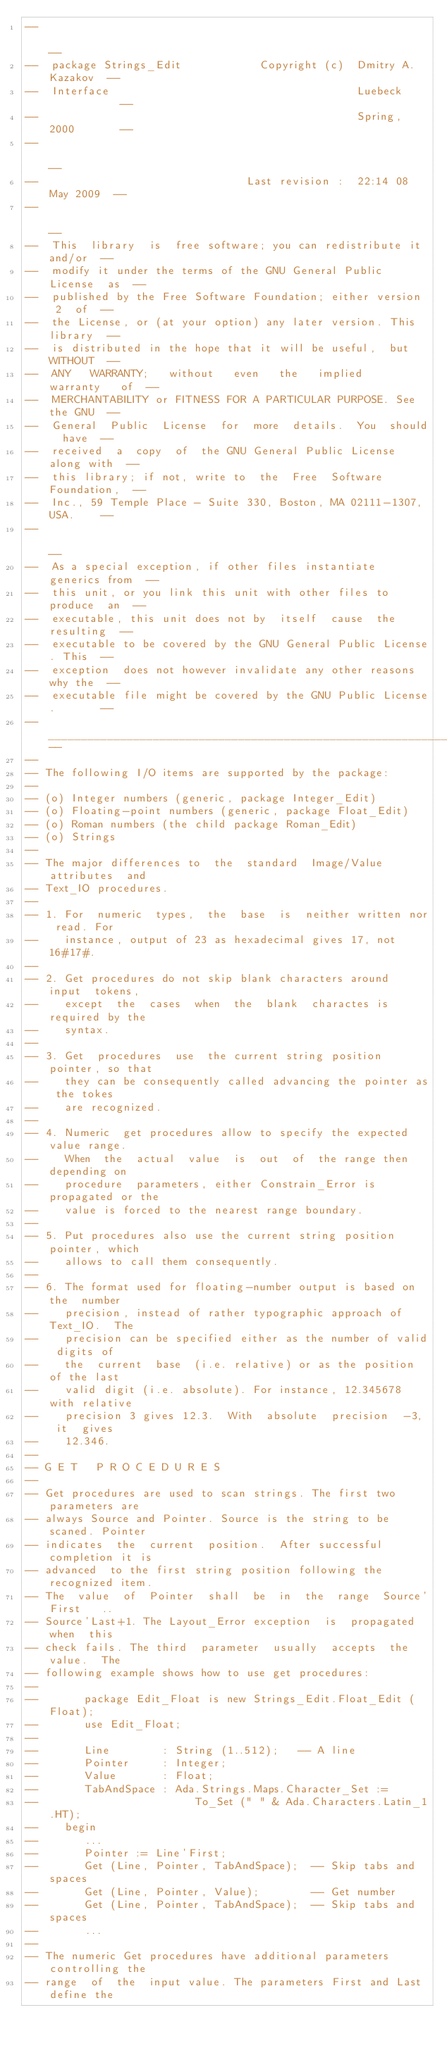Convert code to text. <code><loc_0><loc_0><loc_500><loc_500><_Ada_>--                                                                    --
--  package Strings_Edit            Copyright (c)  Dmitry A. Kazakov  --
--  Interface                                      Luebeck            --
--                                                 Spring, 2000       --
--                                                                    --
--                                Last revision :  22:14 08 May 2009  --
--                                                                    --
--  This  library  is  free software; you can redistribute it and/or  --
--  modify it under the terms of the GNU General Public  License  as  --
--  published by the Free Software Foundation; either version  2  of  --
--  the License, or (at your option) any later version. This library  --
--  is distributed in the hope that it will be useful,  but  WITHOUT  --
--  ANY   WARRANTY;   without   even   the   implied   warranty   of  --
--  MERCHANTABILITY or FITNESS FOR A PARTICULAR PURPOSE. See the GNU  --
--  General  Public  License  for  more  details.  You  should  have  --
--  received  a  copy  of  the GNU General Public License along with  --
--  this library; if not, write to  the  Free  Software  Foundation,  --
--  Inc., 59 Temple Place - Suite 330, Boston, MA 02111-1307, USA.    --
--                                                                    --
--  As a special exception, if other files instantiate generics from  --
--  this unit, or you link this unit with other files to produce  an  --
--  executable, this unit does not by  itself  cause  the  resulting  --
--  executable to be covered by the GNU General Public License. This  --
--  exception  does not however invalidate any other reasons why the  --
--  executable file might be covered by the GNU Public License.       --
--____________________________________________________________________--
--
-- The following I/O items are supported by the package:
--
-- (o) Integer numbers (generic, package Integer_Edit)
-- (o) Floating-point numbers (generic, package Float_Edit)
-- (o) Roman numbers (the child package Roman_Edit)
-- (o) Strings
--
-- The major differences to  the  standard  Image/Value  attributes  and
-- Text_IO procedures.
--
-- 1. For  numeric  types,  the  base  is  neither written nor read. For
--    instance, output of 23 as hexadecimal gives 17, not 16#17#.
--
-- 2. Get procedures do not skip blank characters around  input  tokens,
--    except  the  cases  when  the  blank  charactes is required by the
--    syntax.
--
-- 3. Get  procedures  use  the current string position pointer, so that
--    they can be consequently called advancing the pointer as the tokes
--    are recognized.
--
-- 4. Numeric  get procedures allow to specify the expected value range.
--    When  the  actual  value  is  out  of  the range then depending on
--    procedure  parameters, either Constrain_Error is propagated or the
--    value is forced to the nearest range boundary.
--
-- 5. Put procedures also use the current string position pointer, which
--    allows to call them consequently.
--
-- 6. The format used for floating-number output is based on the  number
--    precision, instead of rather typographic approach of Text_IO.  The
--    precision can be specified either as the number of valid digits of
--    the  current  base  (i.e. relative) or as the position of the last
--    valid digit (i.e. absolute). For instance, 12.345678 with relative
--    precision 3 gives 12.3.  With  absolute  precision  -3,  it  gives
--    12.346.
--
-- G E T   P R O C E D U R E S
--
-- Get procedures are used to scan strings. The first two parameters are
-- always Source and Pointer. Source is the string to be scaned. Pointer
-- indicates  the  current  position.  After successful completion it is
-- advanced  to the first string position following the recognized item.
-- The  value  of  Pointer  shall  be  in  the  range  Source'First   ..
-- Source'Last+1. The Layout_Error exception  is  propagated  when  this
-- check fails. The third  parameter  usually  accepts  the  value.  The
-- following example shows how to use get procedures:
--
--       package Edit_Float is new Strings_Edit.Float_Edit (Float);
--       use Edit_Float;
--
--       Line        : String (1..512);   -- A line
--       Pointer     : Integer;
--       Value       : Float;
--       TabAndSpace : Ada.Strings.Maps.Character_Set :=
--                        To_Set (" " & Ada.Characters.Latin_1.HT);
--    begin
--       ...
--       Pointer := Line'First;
--       Get (Line, Pointer, TabAndSpace);  -- Skip tabs and spaces
--       Get (Line, Pointer, Value);        -- Get number
--       Get (Line, Pointer, TabAndSpace);  -- Skip tabs and spaces
--       ...
--
-- The numeric Get procedures have additional parameters controlling the
-- range  of  the  input value. The parameters First and Last define the</code> 